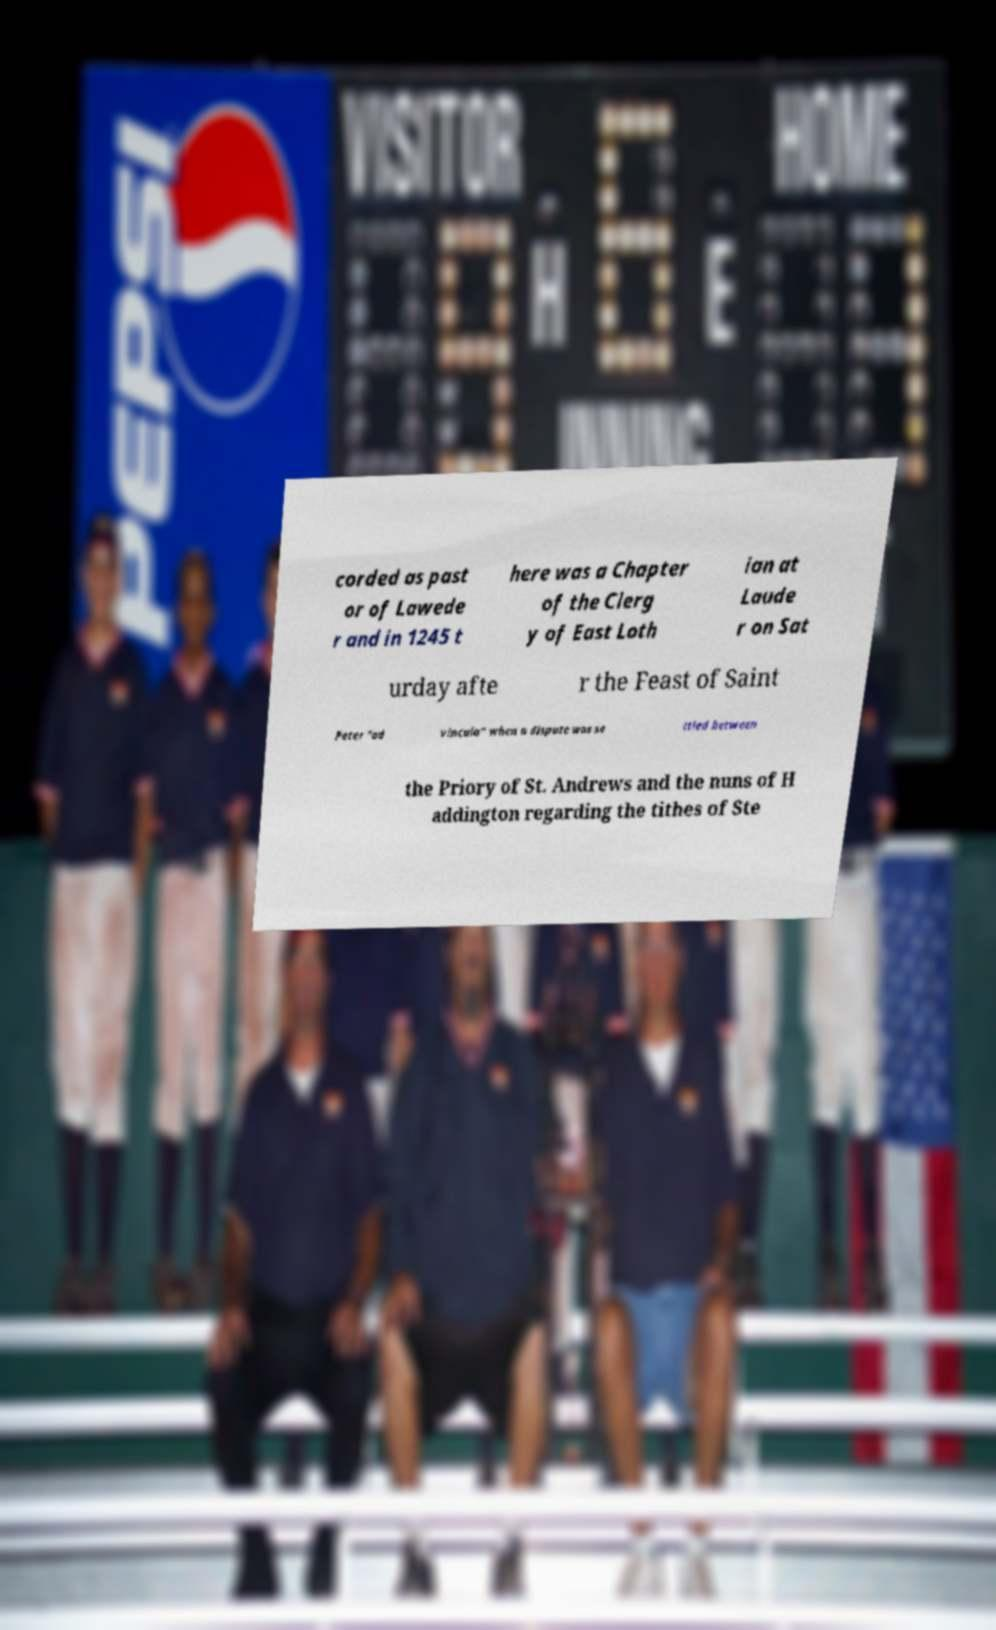Please read and relay the text visible in this image. What does it say? corded as past or of Lawede r and in 1245 t here was a Chapter of the Clerg y of East Loth ian at Laude r on Sat urday afte r the Feast of Saint Peter "ad vincula" when a dispute was se ttled between the Priory of St. Andrews and the nuns of H addington regarding the tithes of Ste 